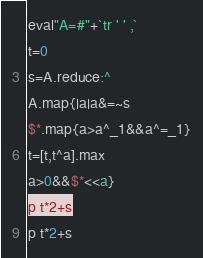<code> <loc_0><loc_0><loc_500><loc_500><_Ruby_>eval"A=#"+`tr ' ' ,`
t=0
s=A.reduce:^
A.map{|a|a&=~s
$*.map{a>a^_1&&a^=_1}
t=[t,t^a].max
a>0&&$*<<a}
p t*2+s</code> 